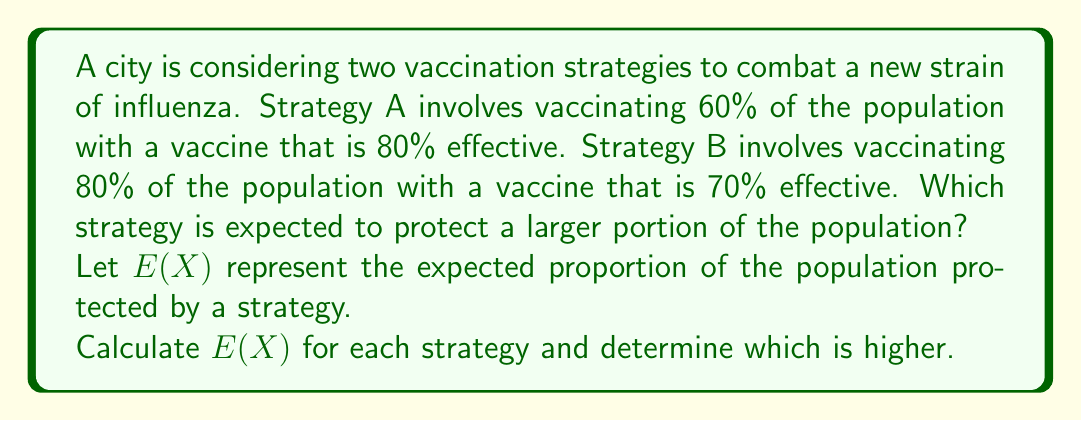Show me your answer to this math problem. To solve this problem, we need to calculate the expected value of protection for each strategy:

1. For Strategy A:
   - Proportion of population vaccinated: 60% = 0.60
   - Vaccine effectiveness: 80% = 0.80
   
   $E(X_A) = 0.60 \times 0.80 = 0.48$

2. For Strategy B:
   - Proportion of population vaccinated: 80% = 0.80
   - Vaccine effectiveness: 70% = 0.70
   
   $E(X_B) = 0.80 \times 0.70 = 0.56$

3. Compare the results:
   $E(X_B) > E(X_A)$
   $0.56 > 0.48$

Therefore, Strategy B is expected to protect a larger portion of the population.

The difference in protection is:
$0.56 - 0.48 = 0.08$ or 8% of the total population.
Answer: Strategy B (56% protected vs. 48% for Strategy A) 